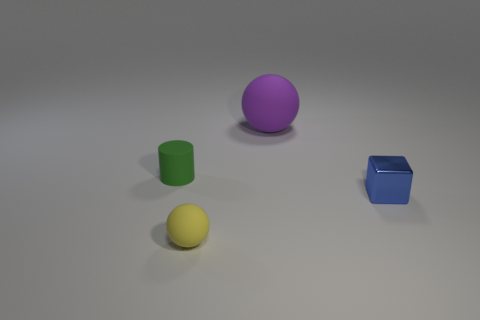Add 4 small green matte things. How many objects exist? 8 Subtract all cylinders. How many objects are left? 3 Add 1 rubber balls. How many rubber balls are left? 3 Add 3 big brown rubber objects. How many big brown rubber objects exist? 3 Subtract 0 red blocks. How many objects are left? 4 Subtract all blue blocks. Subtract all green rubber objects. How many objects are left? 2 